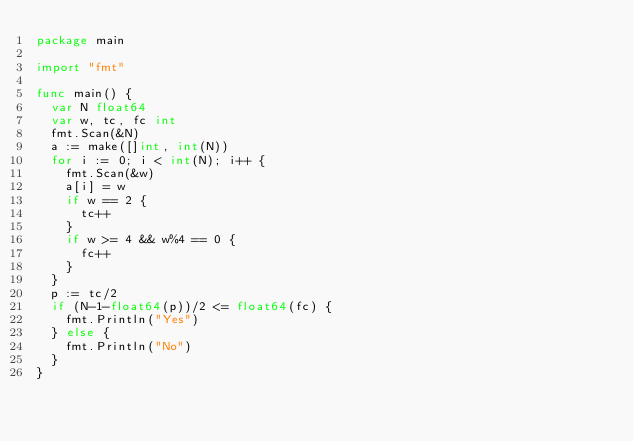Convert code to text. <code><loc_0><loc_0><loc_500><loc_500><_Go_>package main

import "fmt"

func main() {
	var N float64
	var w, tc, fc int
	fmt.Scan(&N)
	a := make([]int, int(N))
	for i := 0; i < int(N); i++ {
		fmt.Scan(&w)
		a[i] = w
		if w == 2 {
			tc++
		}
		if w >= 4 && w%4 == 0 {
			fc++
		}
	}
	p := tc/2
	if (N-1-float64(p))/2 <= float64(fc) {
		fmt.Println("Yes")
	} else {
		fmt.Println("No")
	}
}</code> 